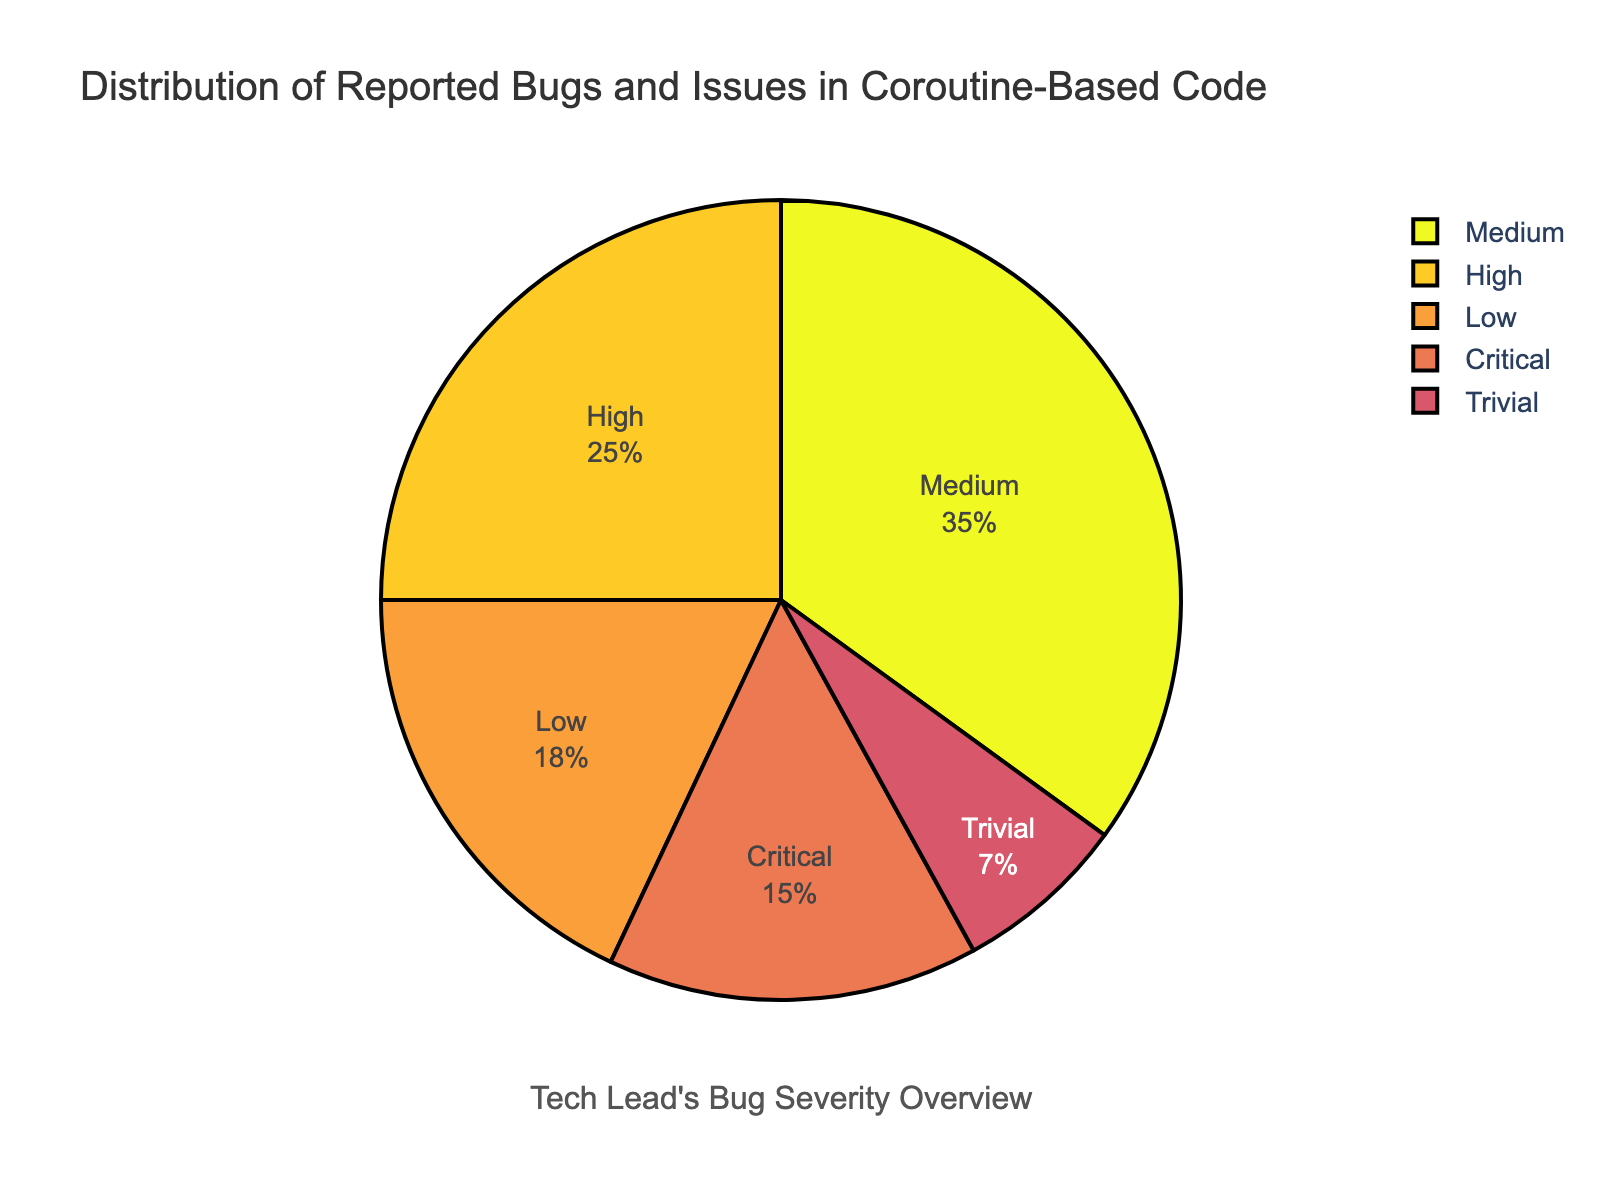What's the most common severity level for reported bugs and issues? The pie chart shows that the medium severity level has the largest slice. This indicates that medium severity issues are the most common.
Answer: Medium What's the total percentage of reported bugs categorized as high and critical severity levels? Add the percentages of high and critical severity levels from the pie chart: 25% (high) + 15% (critical) = 40%.
Answer: 40% What's the least common severity level for reported bugs and issues? The pie chart segment for trivial severity is the smallest, indicating it is the least common.
Answer: Trivial Compare the combined percentage of medium and low severity issues with high severity issues. Which is greater? Calculate the combined percentage of medium and low severity (35% + 18% = 53%) and compare it with high severity (25%). 53% is greater than 25%.
Answer: Combined percentage of medium and low is greater What percentage of issues are categorized below high severity (including high)? Add the percentages for high, medium, low, and trivial: 25% + 35% + 18% + 7% = 85%.
Answer: 85% What's the difference between the percentages of medium and critical issues? Subtract the percentage of critical issues from the percentage of medium issues: 35% - 15% = 20%.
Answer: 20% Which severity levels have a combined percentage less than or equal to 50%? Sum the percentages of all possible combinations to find those ≤ 50%. Low (18%) + Trivial (7%) + Critical (15%) = 40%, Medium (35%) + Trivial (7%) = 42%, High (25%) + Trivial (7%) = 32%, Low (18%) + Trivial (7%) = 25%, No other combinations ≤ 50%.
Answer: Low, Trivial, Critical; Medium, Trivial; High, Trivial What is the combined percentage of non-critical issues? Add the percentages of high, medium, low, and trivial issues: 25% + 35% + 18% + 7% = 85%.
Answer: 85% Compare the percentage of medium issues with the combined percentage of low and trivial issues. Which is greater? Add the percentages of low and trivial issues: 18% + 7% = 25%, and compare with medium issues: 35%. 35% is greater than 25%.
Answer: Medium issues are greater 